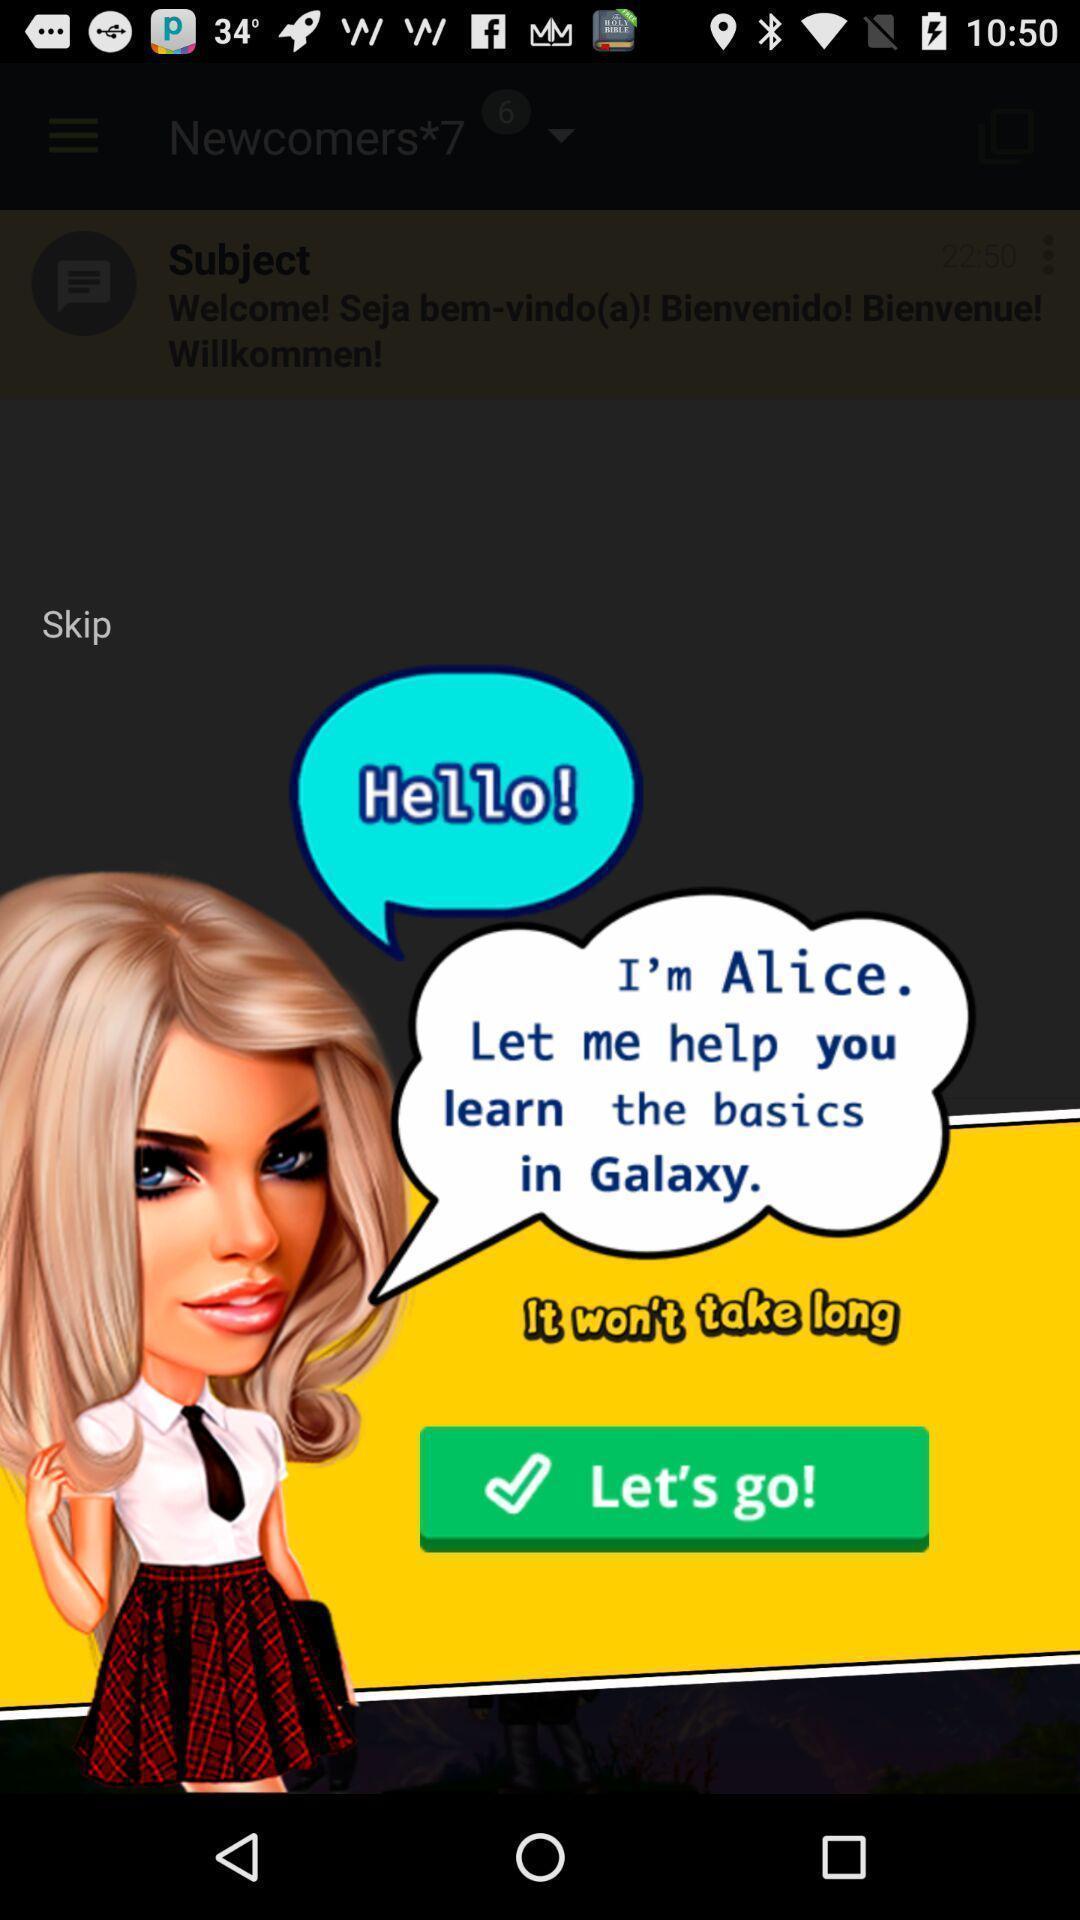What is the overall content of this screenshot? Welcome page of a social application. 